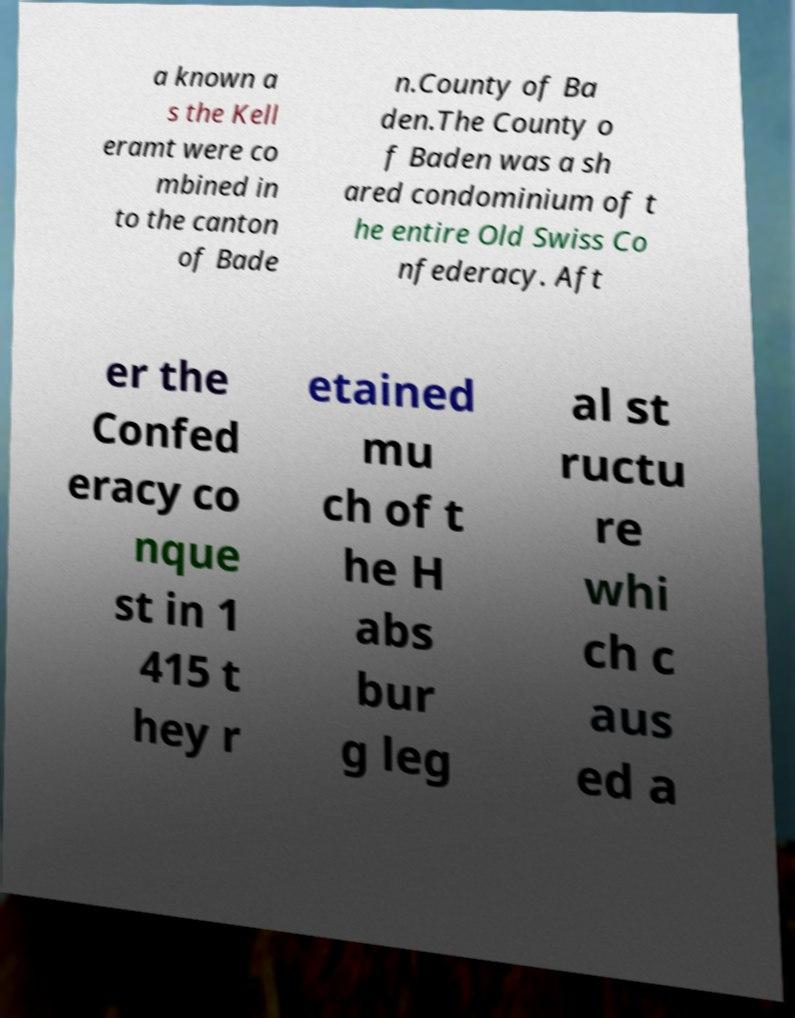Can you accurately transcribe the text from the provided image for me? a known a s the Kell eramt were co mbined in to the canton of Bade n.County of Ba den.The County o f Baden was a sh ared condominium of t he entire Old Swiss Co nfederacy. Aft er the Confed eracy co nque st in 1 415 t hey r etained mu ch of t he H abs bur g leg al st ructu re whi ch c aus ed a 